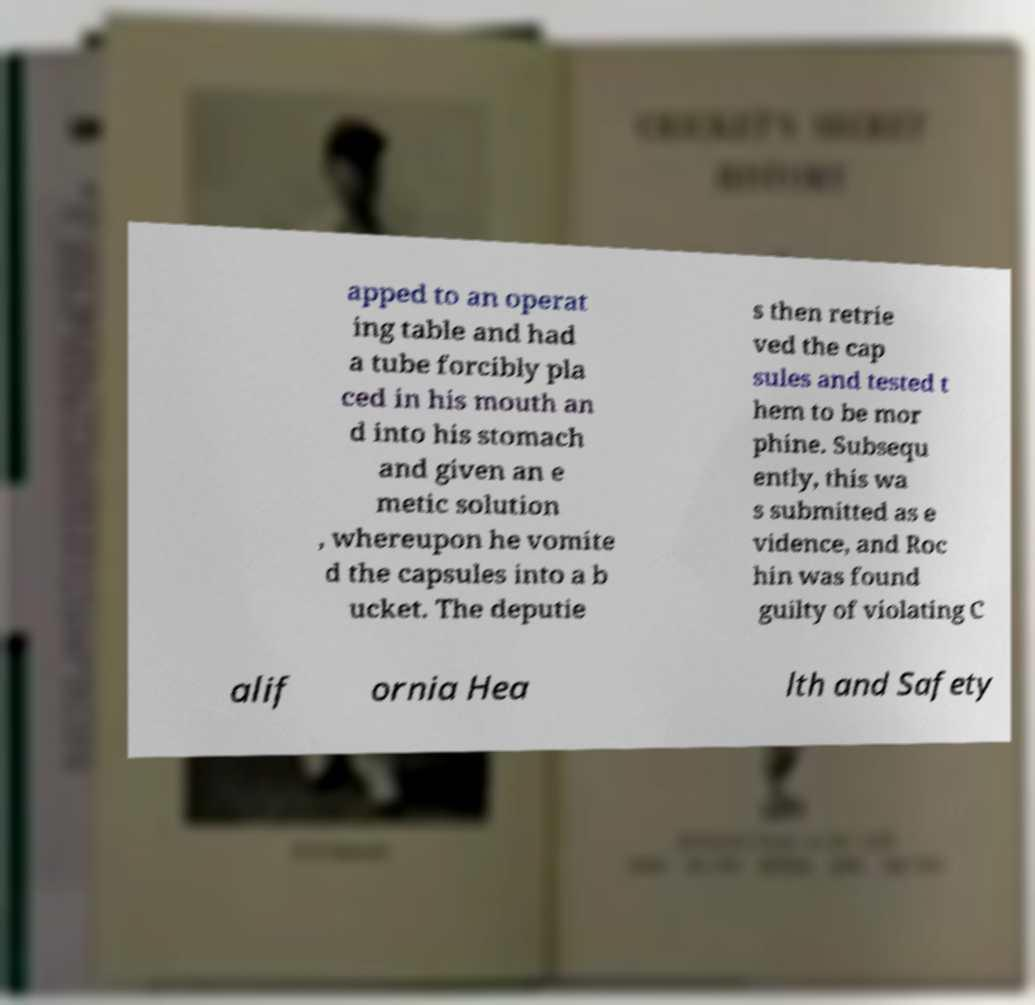Please read and relay the text visible in this image. What does it say? apped to an operat ing table and had a tube forcibly pla ced in his mouth an d into his stomach and given an e metic solution , whereupon he vomite d the capsules into a b ucket. The deputie s then retrie ved the cap sules and tested t hem to be mor phine. Subsequ ently, this wa s submitted as e vidence, and Roc hin was found guilty of violating C alif ornia Hea lth and Safety 